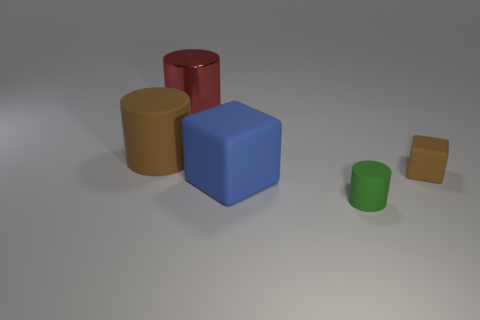Subtract all rubber cylinders. How many cylinders are left? 1 Add 5 big green matte cylinders. How many objects exist? 10 Subtract all large metallic spheres. Subtract all brown cylinders. How many objects are left? 4 Add 4 tiny green cylinders. How many tiny green cylinders are left? 5 Add 5 tiny green matte balls. How many tiny green matte balls exist? 5 Subtract all brown blocks. How many blocks are left? 1 Subtract 0 green balls. How many objects are left? 5 Subtract all cylinders. How many objects are left? 2 Subtract 1 blocks. How many blocks are left? 1 Subtract all purple cubes. Subtract all red cylinders. How many cubes are left? 2 